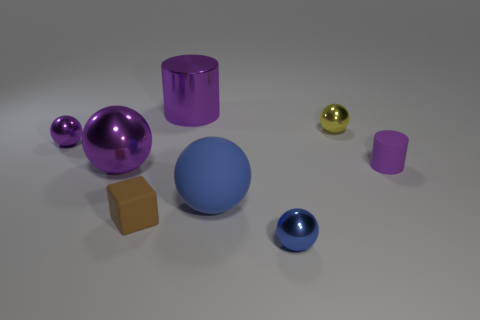Subtract all rubber spheres. How many spheres are left? 4 Subtract all blocks. How many objects are left? 7 Add 2 big purple metal balls. How many big purple metal balls exist? 3 Add 1 purple spheres. How many objects exist? 9 Subtract all purple spheres. How many spheres are left? 3 Subtract 0 cyan cubes. How many objects are left? 8 Subtract 2 cylinders. How many cylinders are left? 0 Subtract all brown cylinders. Subtract all red balls. How many cylinders are left? 2 Subtract all cyan cubes. How many gray cylinders are left? 0 Subtract all small metal things. Subtract all tiny blue objects. How many objects are left? 4 